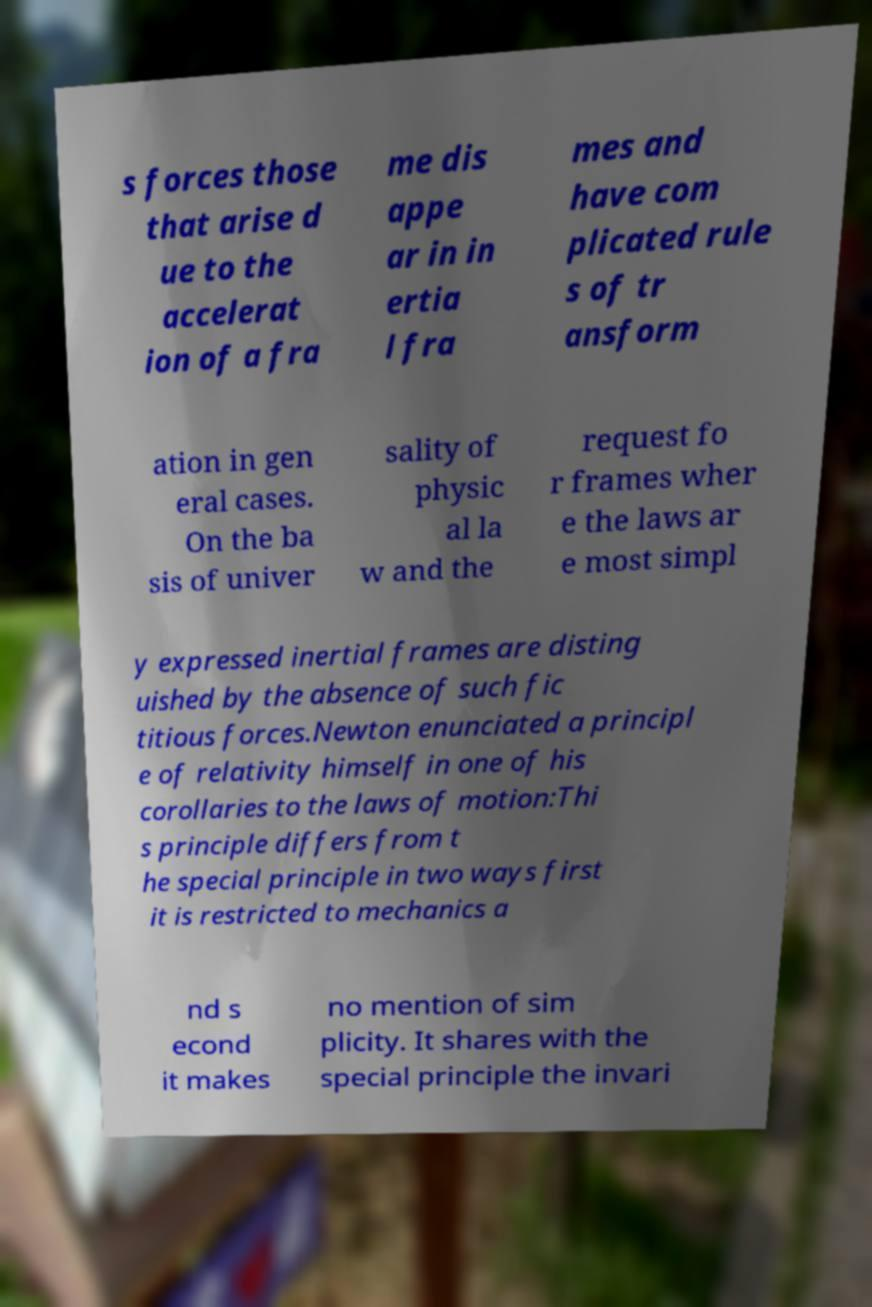For documentation purposes, I need the text within this image transcribed. Could you provide that? s forces those that arise d ue to the accelerat ion of a fra me dis appe ar in in ertia l fra mes and have com plicated rule s of tr ansform ation in gen eral cases. On the ba sis of univer sality of physic al la w and the request fo r frames wher e the laws ar e most simpl y expressed inertial frames are disting uished by the absence of such fic titious forces.Newton enunciated a principl e of relativity himself in one of his corollaries to the laws of motion:Thi s principle differs from t he special principle in two ways first it is restricted to mechanics a nd s econd it makes no mention of sim plicity. It shares with the special principle the invari 